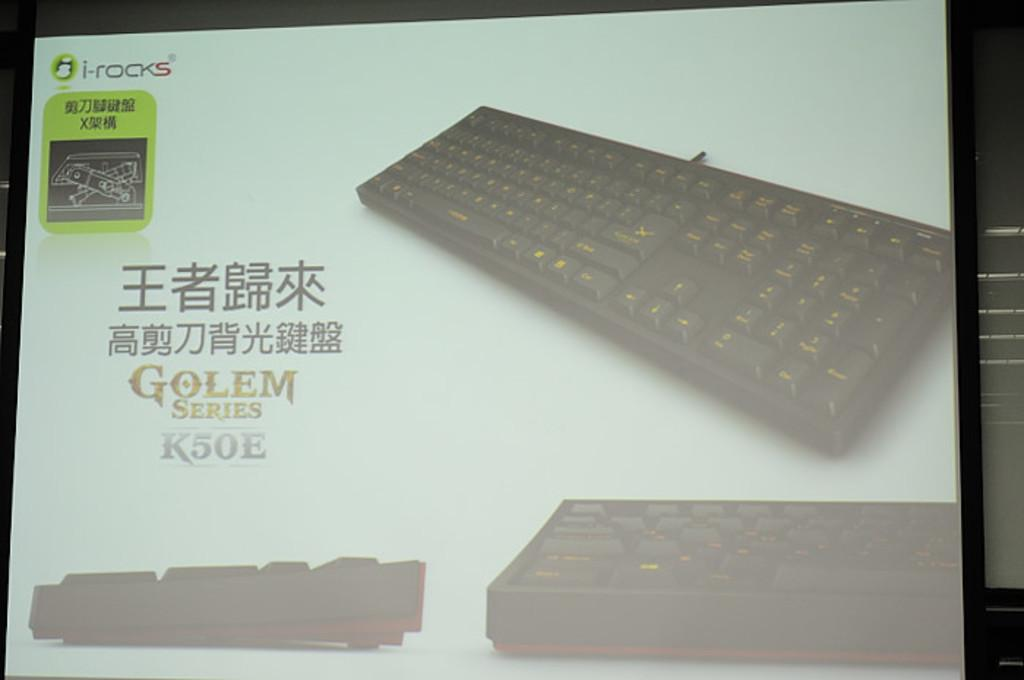<image>
Relay a brief, clear account of the picture shown. a screen display for i-rocks in the upper left corner shows a black Keyboard 